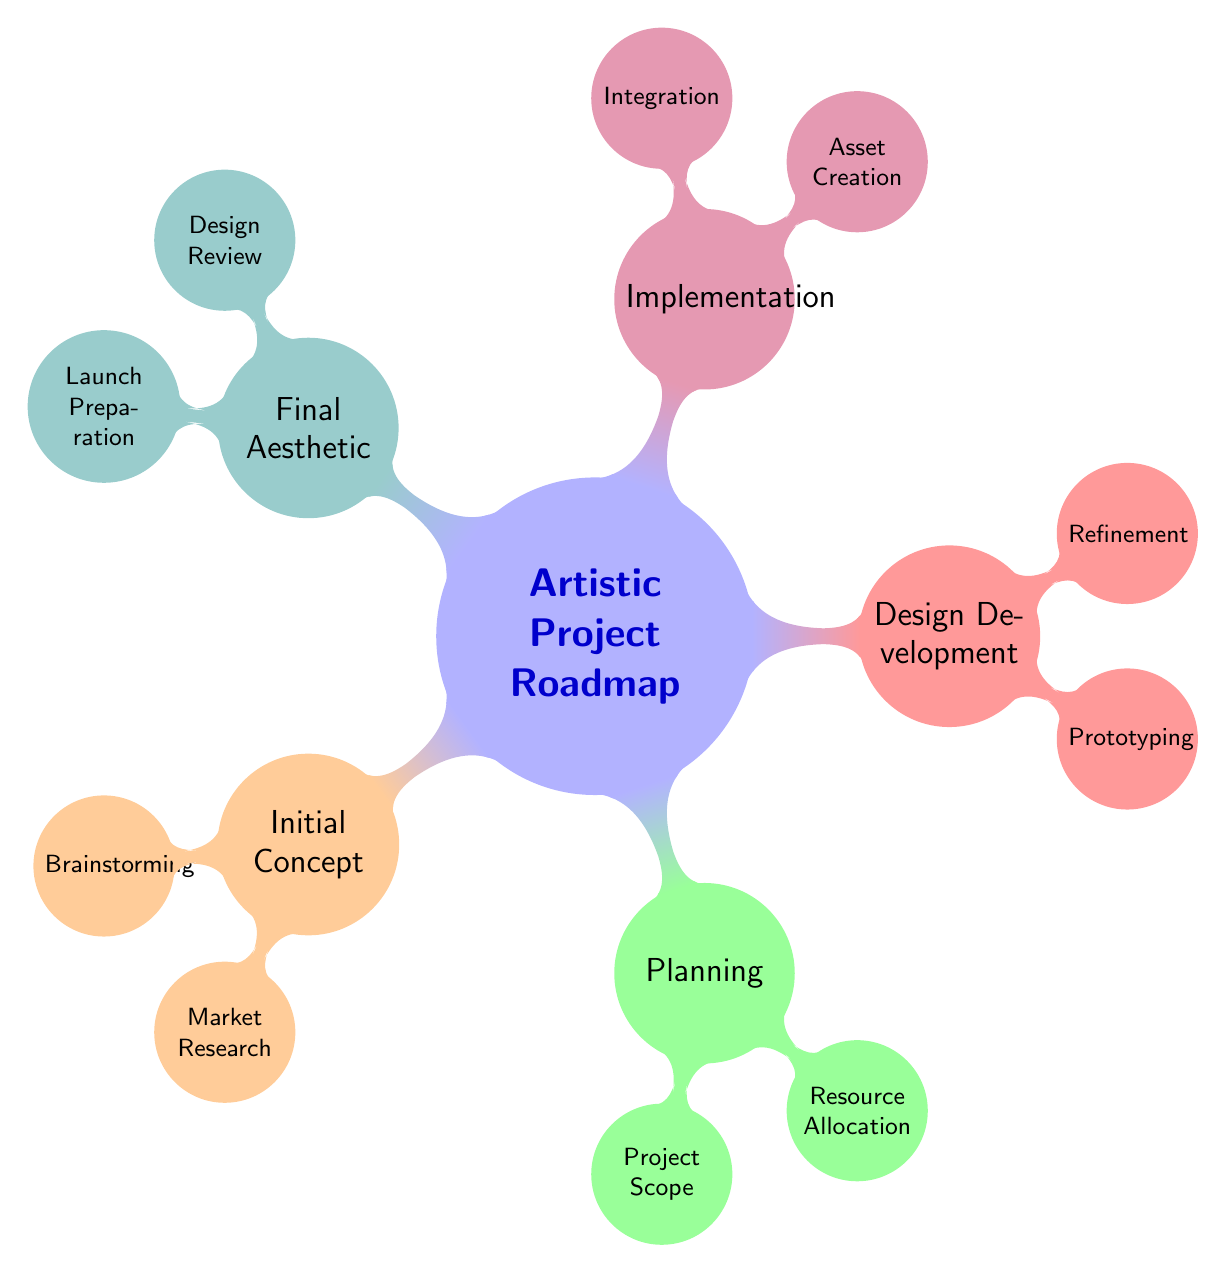What are the two main categories of the roadmap? The diagram presents five main categories, and the question asks for the two main categories. The top-level nodes branching from "Artistic Project Roadmap" are "Initial Concept" and "Planning", providing two distinct aspects of project development.
Answer: Initial Concept, Planning How many nodes are there in the "Design Development" section? To find the number of nodes in the "Design Development" section, we look specifically at the children of that node. The section has two direct child nodes: "Prototyping" and "Refinement". Thus, the count is two.
Answer: 2 What is one activity under "Brainstorming"? By examining the "Brainstorming" node, we can identify the sub-nodes or activities listed below it. One of these activities is "Sketch ideas". Hence, this provides the specific answer requested from the diagram.
Answer: Sketch ideas Which section includes the "Integration" node? To answer this question, we trace upward from the "Integration" node to identify its parent. "Integration" is a child of "Implementation", which indicates that this section encompasses the integration aspect of the project development.
Answer: Implementation Which color represents the "Final Aesthetic" category? The color associated with "Final Aesthetic" can be determined by identifying the color coded to this specific node in the diagram. It is colored teal. Therefore, this is the answer.
Answer: Teal How many nodes are under "Planning"? We examine the sub-nodes under the "Planning" node. There are two nodes mentioned in this section: "Project Scope" and "Resource Allocation". This gives a total count of two nodes.
Answer: 2 What is the primary purpose of the "Design Review"? Looking closely at the "Design Review" node, we see it is related to "Peer evaluation", "Client approval", and "Quality check". The primary purpose can be distilled to the goal of evaluating and calibrating design aspects prior to finalization.
Answer: Evaluation What comes after "Asset Creation" in the implementation phase? To ascertain what comes directly after "Asset Creation", we look at the child nodes of "Implementation". The node immediately following is "Integration", indicating the sequence in the development process.
Answer: Integration In which section would you find the "Mood boards"? The "Mood boards" activity is specifically located under the "Brainstorming" node, which is a child of the "Initial Concept" category. This locates the specific activity in the broader roadmap.
Answer: Initial Concept 